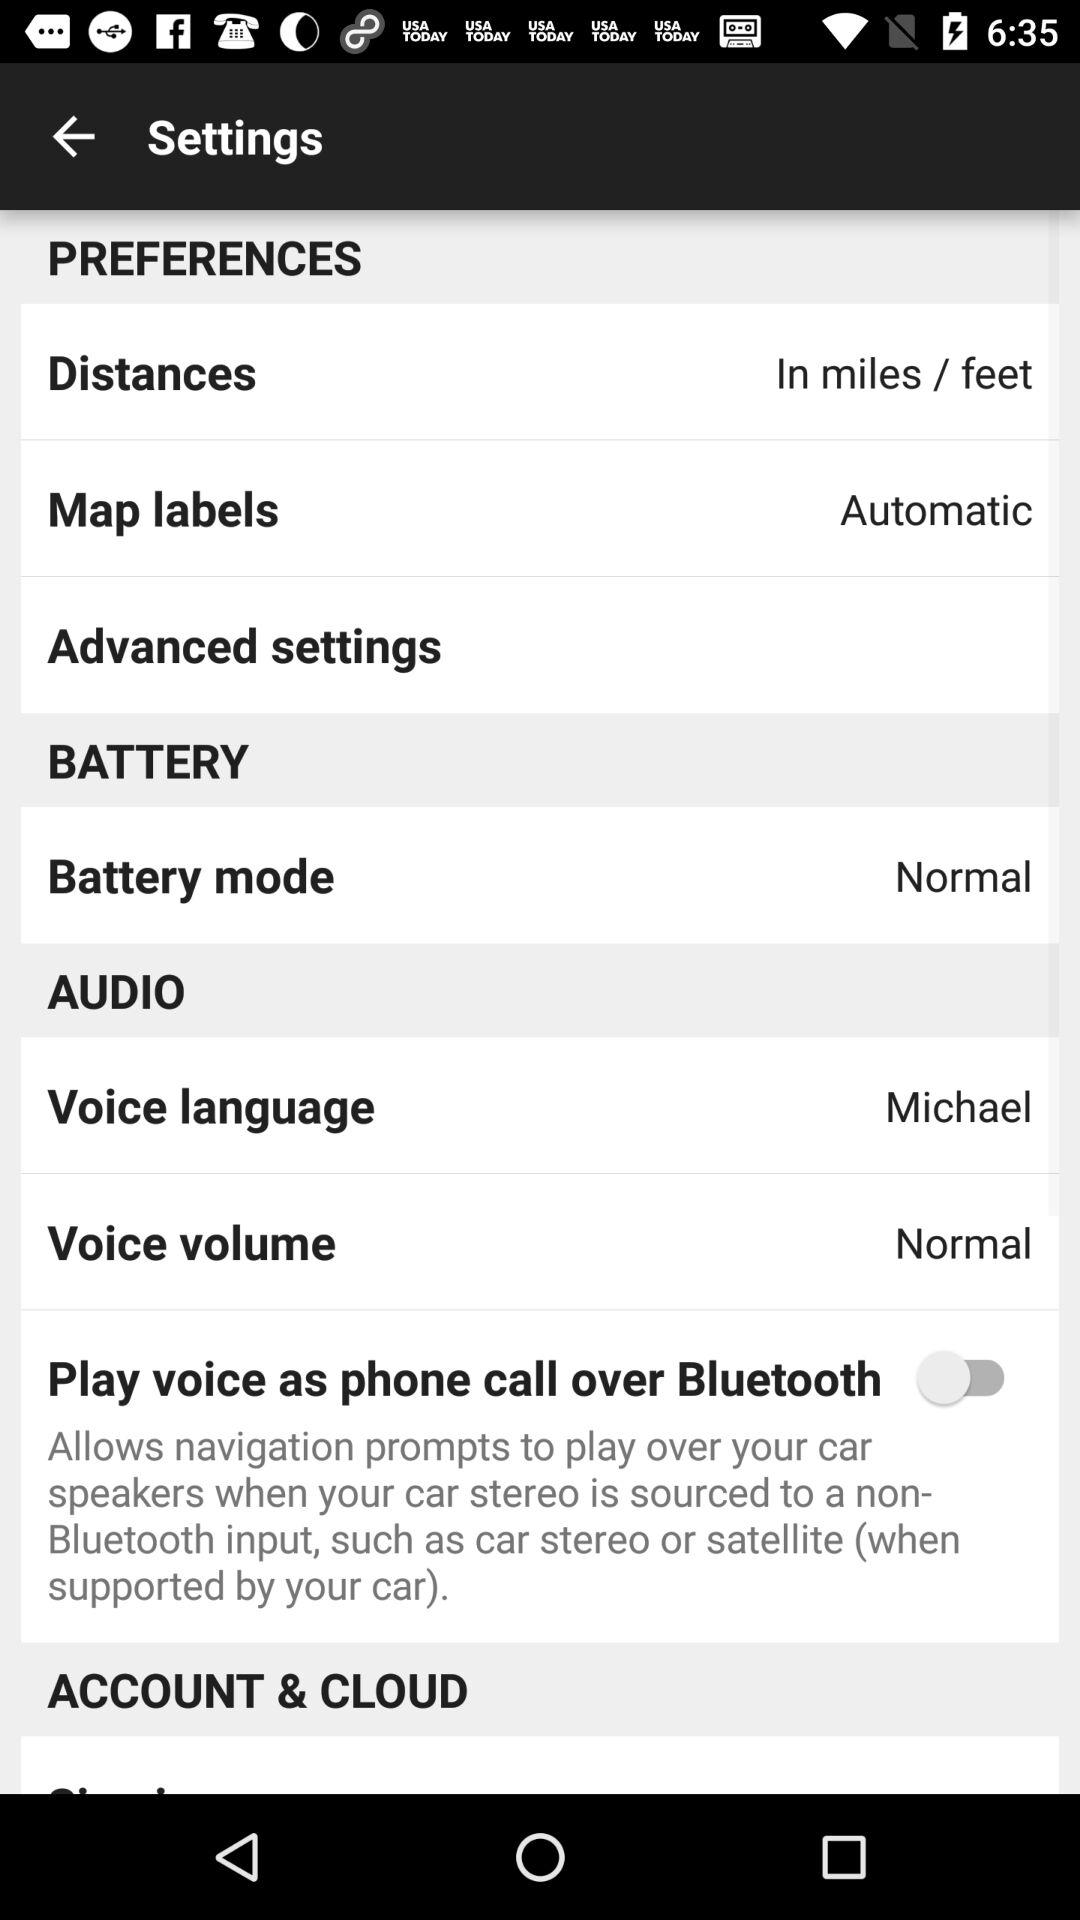How many more items are there in the Audio section than in the Battery section?
Answer the question using a single word or phrase. 2 